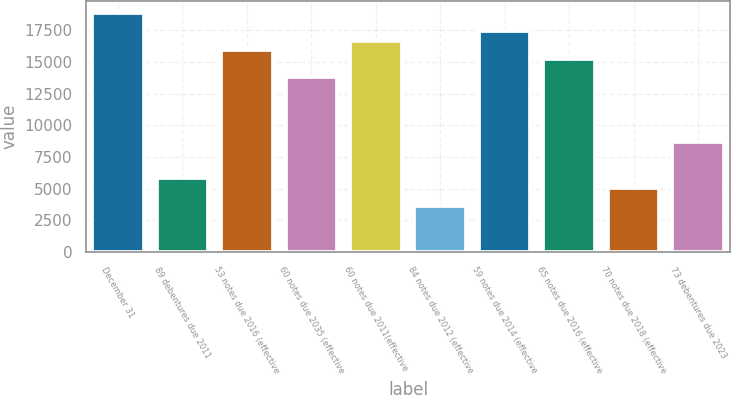Convert chart to OTSL. <chart><loc_0><loc_0><loc_500><loc_500><bar_chart><fcel>December 31<fcel>89 debentures due 2011<fcel>53 notes due 2016 (effective<fcel>60 notes due 2035 (effective<fcel>60 notes due 2011(effective<fcel>84 notes due 2012 (effective<fcel>59 notes due 2014 (effective<fcel>65 notes due 2016 (effective<fcel>70 notes due 2018 (effective<fcel>73 debentures due 2023<nl><fcel>18866<fcel>5807<fcel>15964<fcel>13787.5<fcel>16689.5<fcel>3630.5<fcel>17415<fcel>15238.5<fcel>5081.5<fcel>8709<nl></chart> 